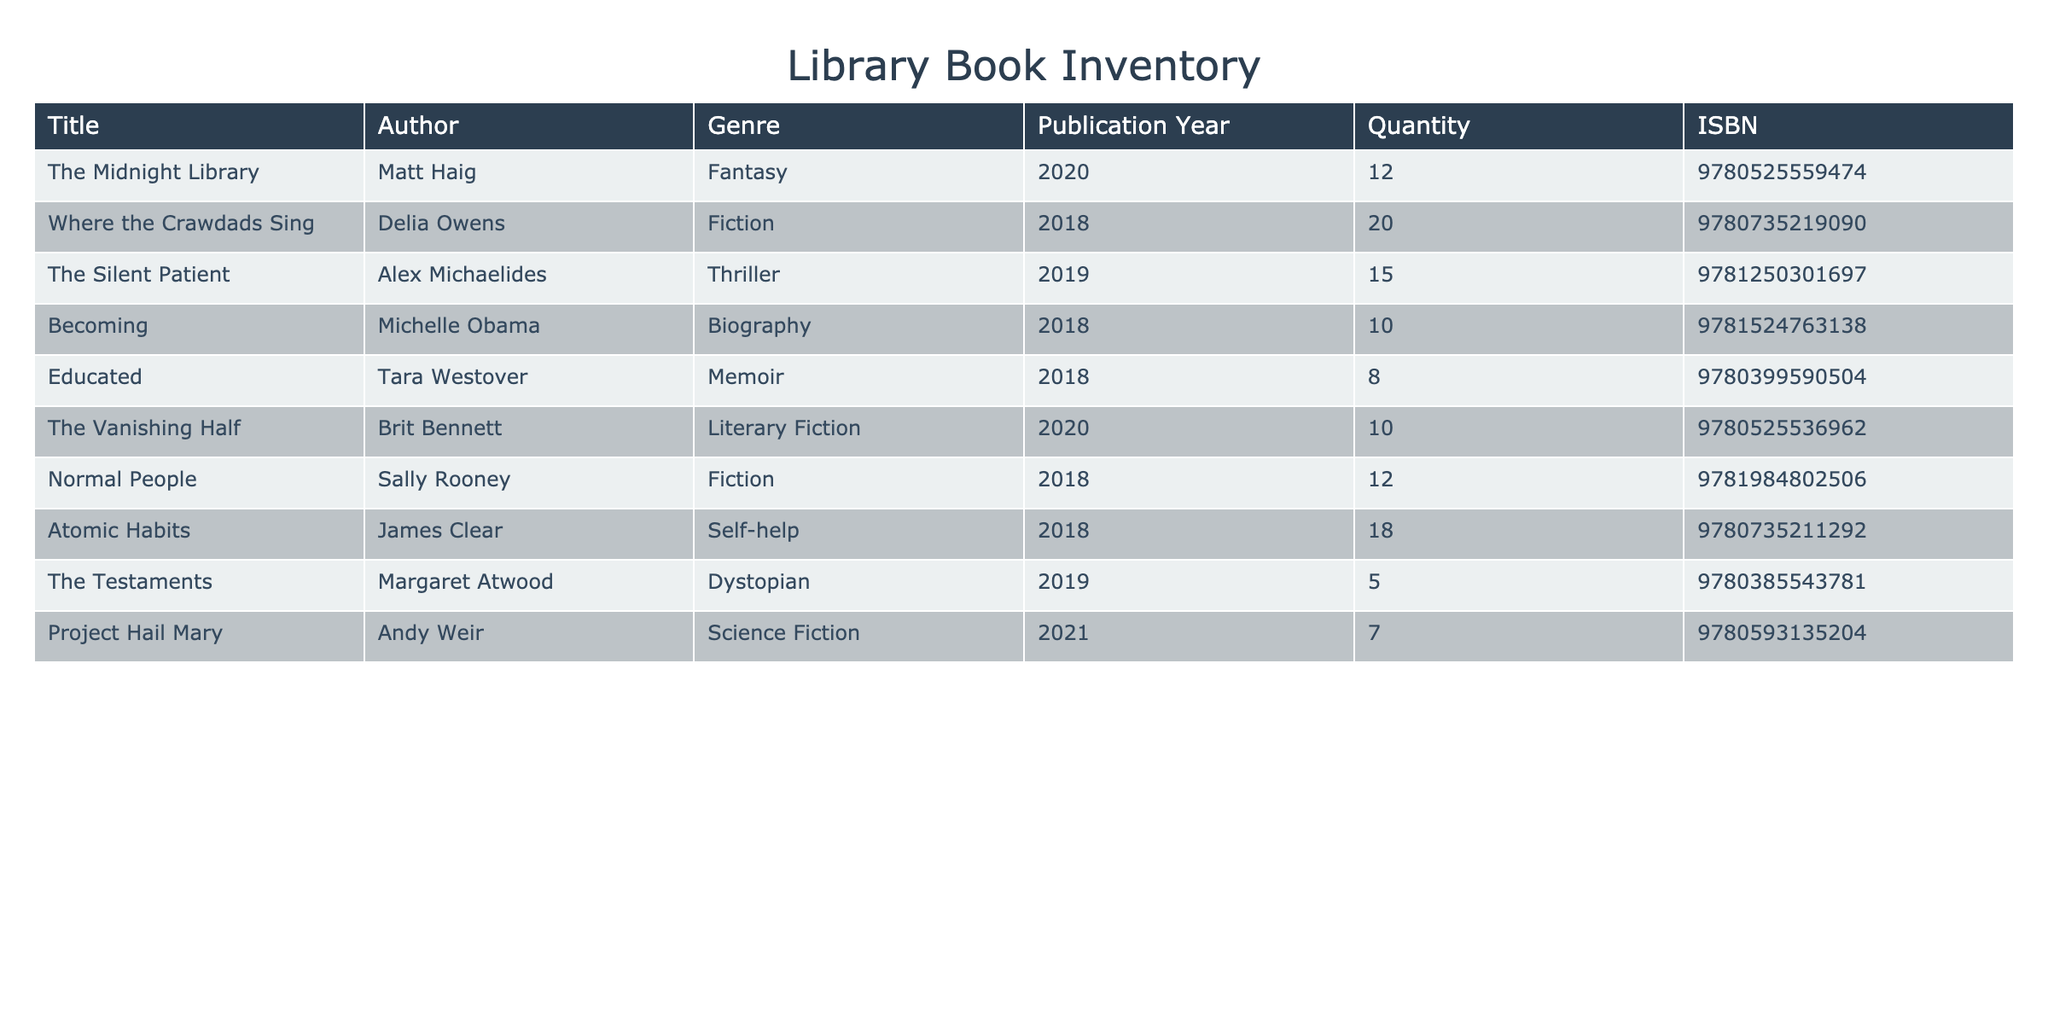What is the total quantity of books in the genre of Fiction? To find the total quantity of Fiction books, I will look for the rows where the Genre is "Fiction". There are two titles: "Where the Crawdads Sing" with a quantity of 20 and "Normal People" with a quantity of 12. Summing these gives us 20 + 12 = 32.
Answer: 32 Which author has the highest quantity of books available? I will compare the Quantity values across all authors. The title with the highest quantity is "Where the Crawdads Sing" by Delia Owens, with a quantity of 20. No other titles exceed this quantity.
Answer: Delia Owens Is there any book in the inventory published before 2018? I will check the Publication Year of all books in the inventory. The earliest publication year is 2018. Therefore, there are no books published before 2018.
Answer: No What is the average quantity of Self-help books in the library? The only Self-help book in the inventory is "Atomic Habits" by James Clear, which has a quantity of 18. Since there is only one self-help book, the average quantity is simply 18.
Answer: 18 How many more copies of "The Silent Patient" are available compared to "The Testaments"? The quantity for "The Silent Patient" is 15 and for "The Testaments" it is 5. I will subtract the two: 15 - 5 = 10, indicating there are 10 more copies of "The Silent Patient".
Answer: 10 What are the two most popular genres based on the quantity of books? First, I will list the total quantities for each genre: Fantasy has 12, Fiction has 32, Thriller has 15, Biography has 10, Memoir has 8, Literary Fiction has 10, Self-help has 18, Dystopian has 5, and Science Fiction has 7. The two highest quantities come from Fiction (32) and Self-help (18).
Answer: Fiction and Self-help Is "Project Hail Mary" the only Science Fiction book listed? I will check if there are other titles in the Science Fiction genre. "Project Hail Mary" is the only title mentioned under Science Fiction in the inventory.
Answer: Yes What is the total quantity of books published in the year 2018? I will identify all titles published in 2018. The titles are "Where the Crawdads Sing" (20), "Becoming" (10), "Educated" (8), and "Normal People" (12). Summing these gives: 20 + 10 + 8 + 12 = 60.
Answer: 60 How many different genres are represented in the library's inventory? I will count the unique genres listed in the inventory. The genres are Fantasy, Fiction, Thriller, Biography, Memoir, Literary Fiction, Self-help, Dystopian, and Science Fiction, which totals 9 different genres.
Answer: 9 